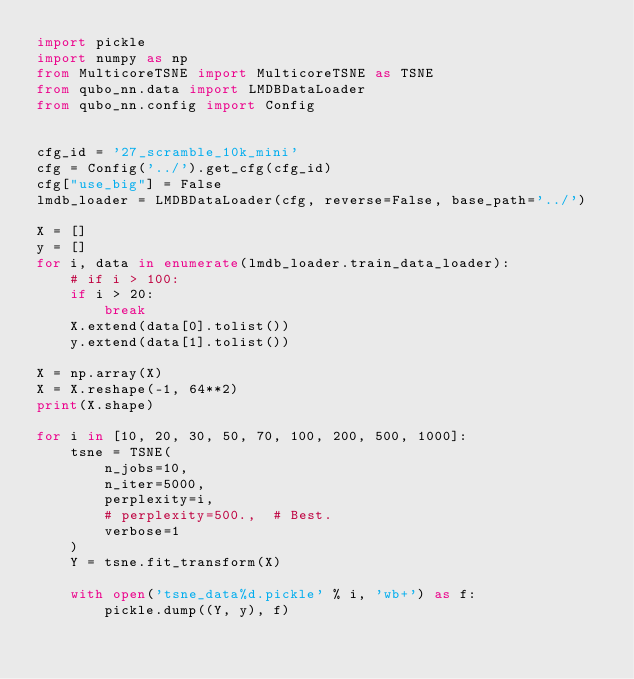<code> <loc_0><loc_0><loc_500><loc_500><_Python_>import pickle
import numpy as np
from MulticoreTSNE import MulticoreTSNE as TSNE
from qubo_nn.data import LMDBDataLoader
from qubo_nn.config import Config


cfg_id = '27_scramble_10k_mini'
cfg = Config('../').get_cfg(cfg_id)
cfg["use_big"] = False
lmdb_loader = LMDBDataLoader(cfg, reverse=False, base_path='../')

X = []
y = []
for i, data in enumerate(lmdb_loader.train_data_loader):
    # if i > 100:
    if i > 20:
        break
    X.extend(data[0].tolist())
    y.extend(data[1].tolist())

X = np.array(X)
X = X.reshape(-1, 64**2)
print(X.shape)

for i in [10, 20, 30, 50, 70, 100, 200, 500, 1000]:
    tsne = TSNE(
        n_jobs=10,
        n_iter=5000,
        perplexity=i,
        # perplexity=500.,  # Best.
        verbose=1
    )
    Y = tsne.fit_transform(X)

    with open('tsne_data%d.pickle' % i, 'wb+') as f:
        pickle.dump((Y, y), f)
</code> 